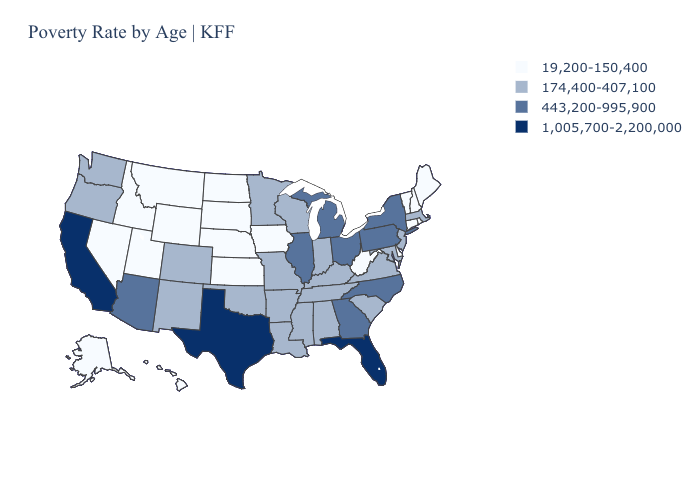Name the states that have a value in the range 1,005,700-2,200,000?
Be succinct. California, Florida, Texas. Name the states that have a value in the range 19,200-150,400?
Write a very short answer. Alaska, Connecticut, Delaware, Hawaii, Idaho, Iowa, Kansas, Maine, Montana, Nebraska, Nevada, New Hampshire, North Dakota, Rhode Island, South Dakota, Utah, Vermont, West Virginia, Wyoming. What is the lowest value in the MidWest?
Short answer required. 19,200-150,400. Does the first symbol in the legend represent the smallest category?
Be succinct. Yes. Name the states that have a value in the range 1,005,700-2,200,000?
Write a very short answer. California, Florida, Texas. Does California have a higher value than Alaska?
Quick response, please. Yes. Does Tennessee have a lower value than Kentucky?
Concise answer only. No. What is the lowest value in the USA?
Short answer required. 19,200-150,400. Name the states that have a value in the range 1,005,700-2,200,000?
Answer briefly. California, Florida, Texas. What is the highest value in the West ?
Be succinct. 1,005,700-2,200,000. Does the first symbol in the legend represent the smallest category?
Answer briefly. Yes. Does Rhode Island have the lowest value in the Northeast?
Quick response, please. Yes. What is the value of Nebraska?
Quick response, please. 19,200-150,400. What is the lowest value in the South?
Quick response, please. 19,200-150,400. Does the map have missing data?
Answer briefly. No. 